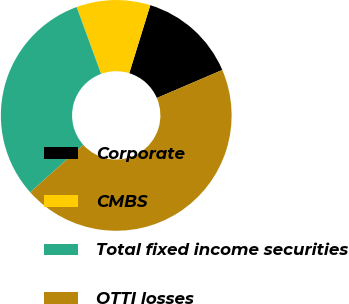Convert chart. <chart><loc_0><loc_0><loc_500><loc_500><pie_chart><fcel>Corporate<fcel>CMBS<fcel>Total fixed income securities<fcel>OTTI losses<nl><fcel>13.79%<fcel>10.34%<fcel>31.03%<fcel>44.83%<nl></chart> 